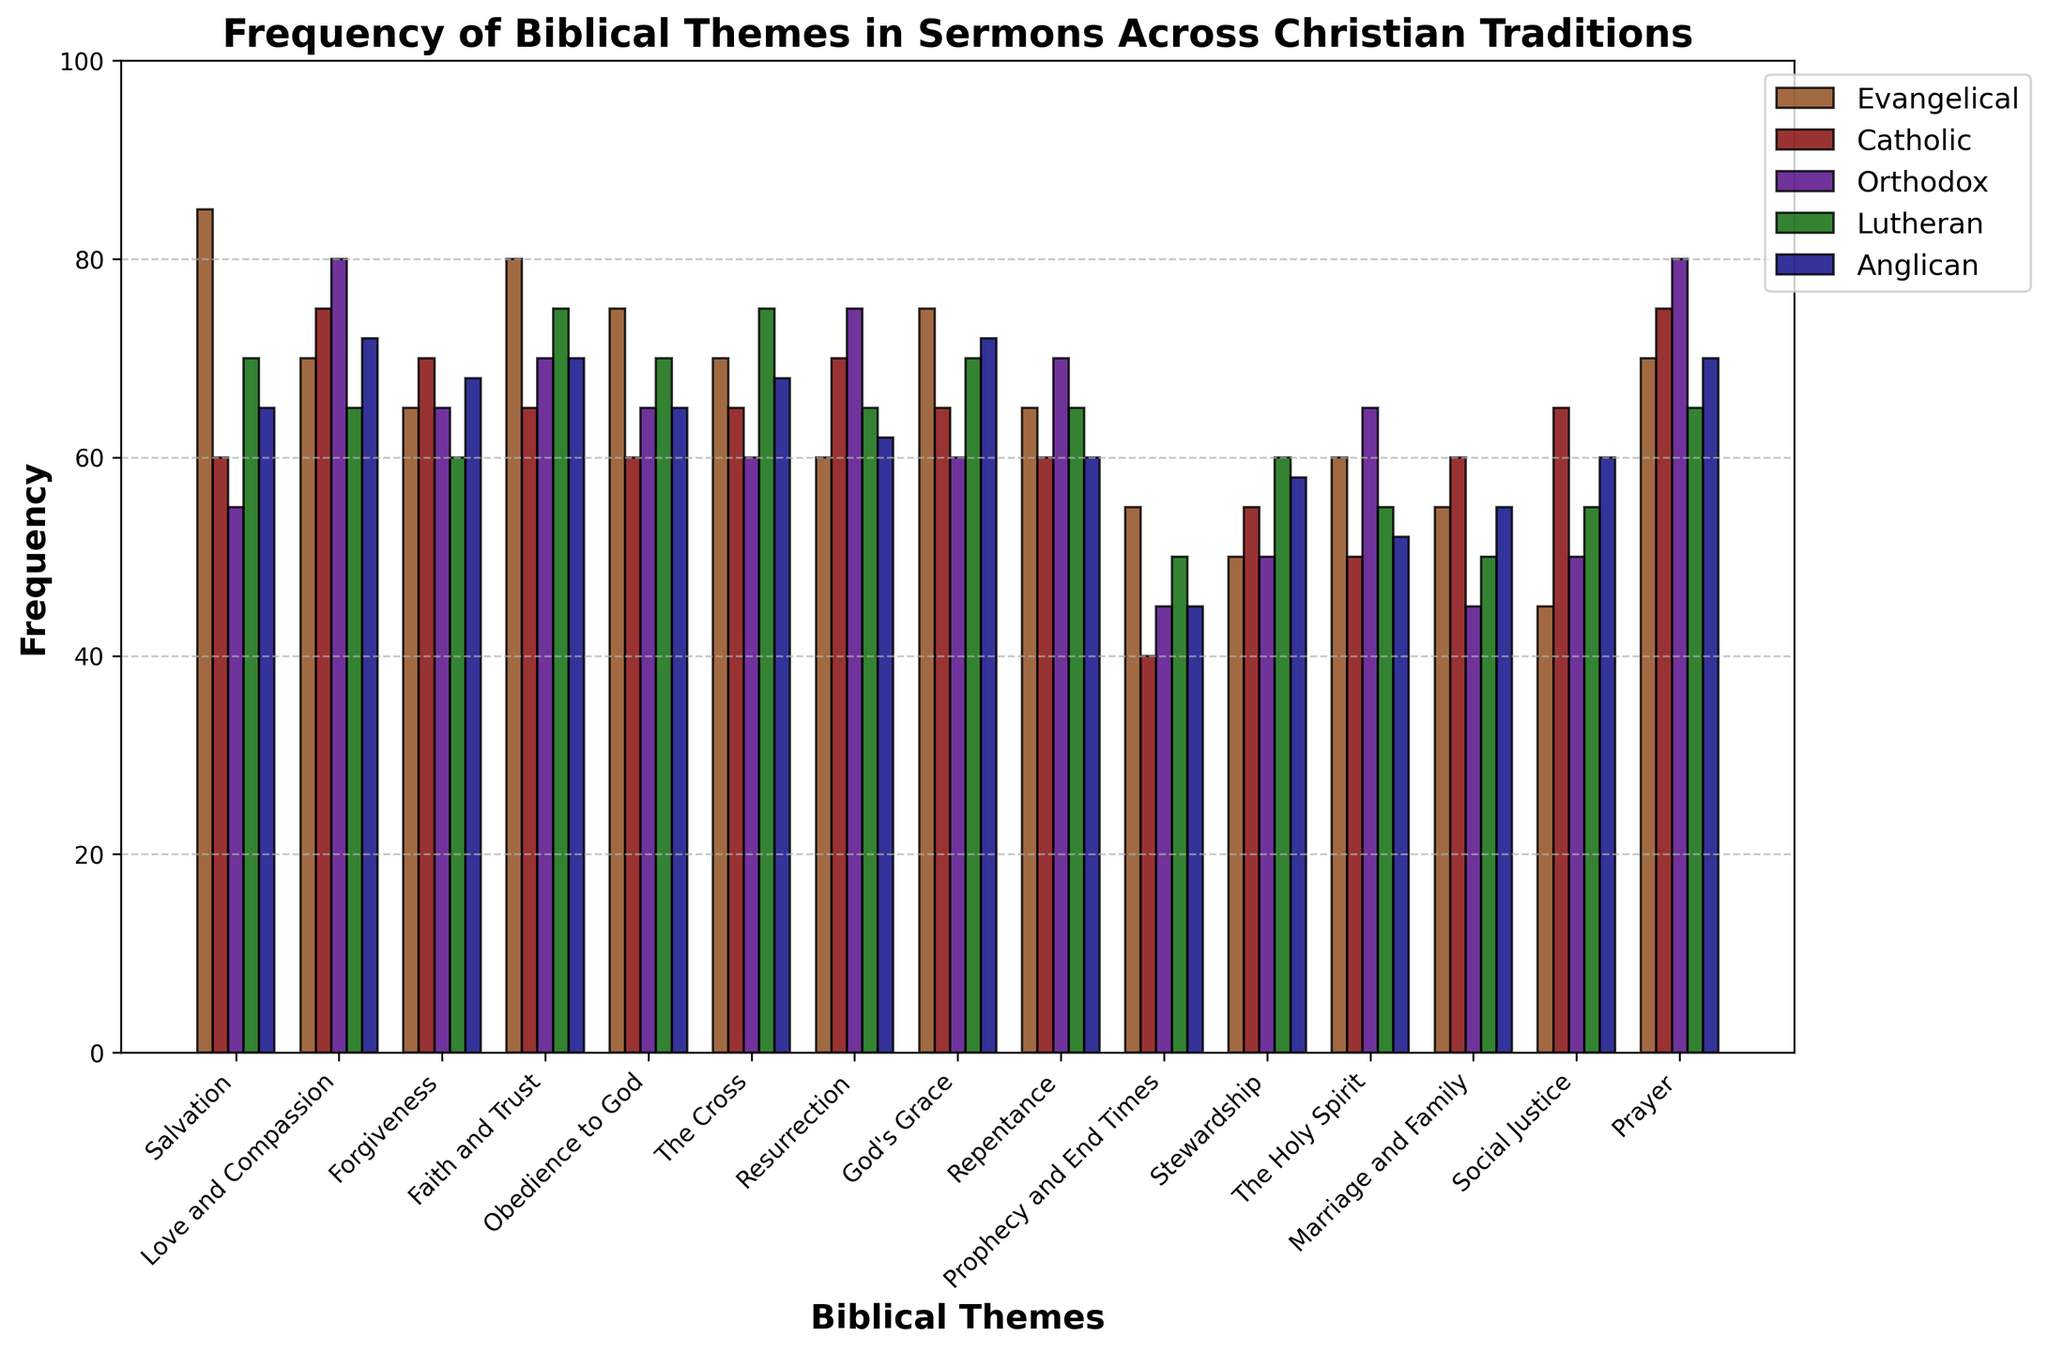Which Christian tradition most frequently includes the theme of "Salvation" in sermons? Look at the bar heights for the theme "Salvation." The Evangelical bar is the tallest among the others.
Answer: Evangelical What is the average frequency of "Love and Compassion" across all traditions? Sum the frequencies of "Love and Compassion" across all traditions (70+75+80+65+72) which equals 362, then divide by the number of traditions, which is 5. The calculation is 362/5 = 72.4.
Answer: 72.4 Compare the frequency of the theme "Prophecy and End Times" in Catholic and Lutheran traditions. Which is higher? Identify the bars for "Prophecy and End Times." The bar for Catholics is 40, and the bar for Lutherans is 50. The Lutheran frequency is higher.
Answer: Lutheran What is the total frequency of the "Forgiveness" theme across Evangelical and Catholic traditions? Sum the frequencies of "Forgiveness" for Evangelical and Catholic. Those values are 65 and 70. Adding them gives 135.
Answer: 135 Which theme is least frequently discussed by Orthodox traditions according to the graph? Look for the shortest bar for Orthodox. The shortest bar corresponds to "Marriage and Family" with a frequency of 45.
Answer: Marriage and Family How much more frequently is "Prayer" discussed in the Lutheran tradition compared to the Catholic tradition? Identify the bar heights for "Prayer." The Lutheran bar is 65 and the Catholic bar is 75. Subtract 65 from 75 to get 10.
Answer: 10 What is the most frequently discussed theme in the Orthodox tradition? Look for the tallest bar among the Orthodox bars. "Love and Compassion" and "Prayer" are equally tall, both with a frequency of 80.
Answer: Love and Compassion, Prayer (tie) Among "Resurrection" in the Orthodox tradition and "The Cross" in the Lutheran tradition, which theme is more frequently discussed? Compare the heights of the bars for "Resurrection" in Orthodox (75) and "The Cross" in Lutheran (75). Both are equally tall.
Answer: Equal Which theme has the second-highest frequency in the Anglican tradition? Identify the heights of the Anglican bars and sort them. "God's Grace" and "Love and Compassion" both have a frequency of 72, which is the second highest after "Prayer" with 70.
Answer: Love and Compassion, God's Grace (tie) What is the difference in frequency for "Obedience to God" between Evangelical and Catholic traditions? Identify the bar heights. The Evangelical frequency is 75, and the Catholic frequency is 60. Subtract 60 from 75 to get 15.
Answer: 15 